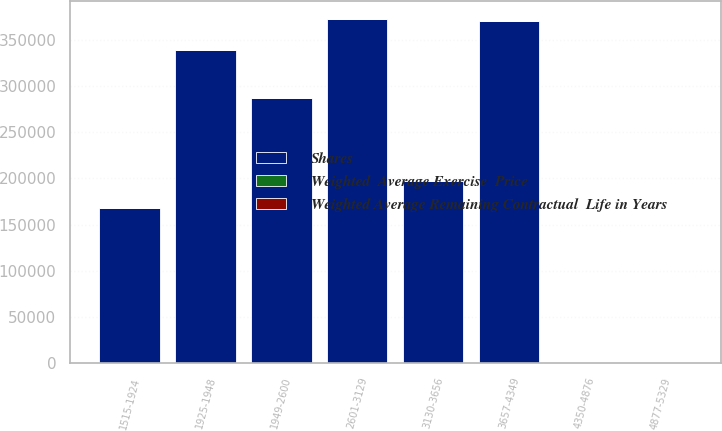<chart> <loc_0><loc_0><loc_500><loc_500><stacked_bar_chart><ecel><fcel>1515-1924<fcel>1925-1948<fcel>1949-2600<fcel>2601-3129<fcel>3130-3656<fcel>3657-4349<fcel>4350-4876<fcel>4877-5329<nl><fcel>Shares<fcel>167438<fcel>338819<fcel>286455<fcel>372767<fcel>196781<fcel>370190<fcel>27.045<fcel>27.045<nl><fcel>Weighted  Average Exercise  Price<fcel>1.86<fcel>5.33<fcel>1.28<fcel>2.32<fcel>0.32<fcel>1.92<fcel>3.97<fcel>4.56<nl><fcel>Weighted Average Remaining Contractual  Life in Years<fcel>17.4<fcel>19.48<fcel>24.62<fcel>29.47<fcel>35.84<fcel>41.93<fcel>47.66<fcel>50.66<nl></chart> 